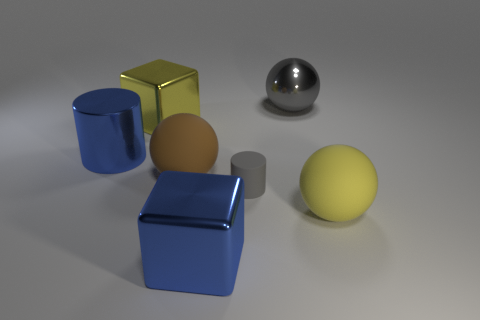Add 3 gray rubber objects. How many objects exist? 10 Subtract all gray balls. How many balls are left? 2 Subtract all yellow spheres. How many spheres are left? 2 Subtract all balls. How many objects are left? 4 Subtract 1 blocks. How many blocks are left? 1 Subtract all cyan balls. Subtract all green cubes. How many balls are left? 3 Subtract all cyan cylinders. How many yellow blocks are left? 1 Subtract all large red cylinders. Subtract all big gray metal spheres. How many objects are left? 6 Add 1 blue metallic cubes. How many blue metallic cubes are left? 2 Add 6 red balls. How many red balls exist? 6 